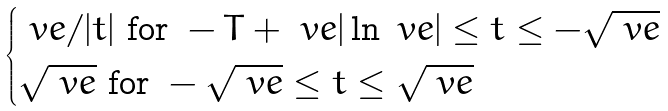Convert formula to latex. <formula><loc_0><loc_0><loc_500><loc_500>\begin{cases} \ v e / | t | \text { for } - T + \ v e | \ln \ v e | \leq t \leq - \sqrt { \ v e } \\ \sqrt { \ v e } \text { for } - \sqrt { \ v e } \leq t \leq \sqrt { \ v e } \end{cases}</formula> 